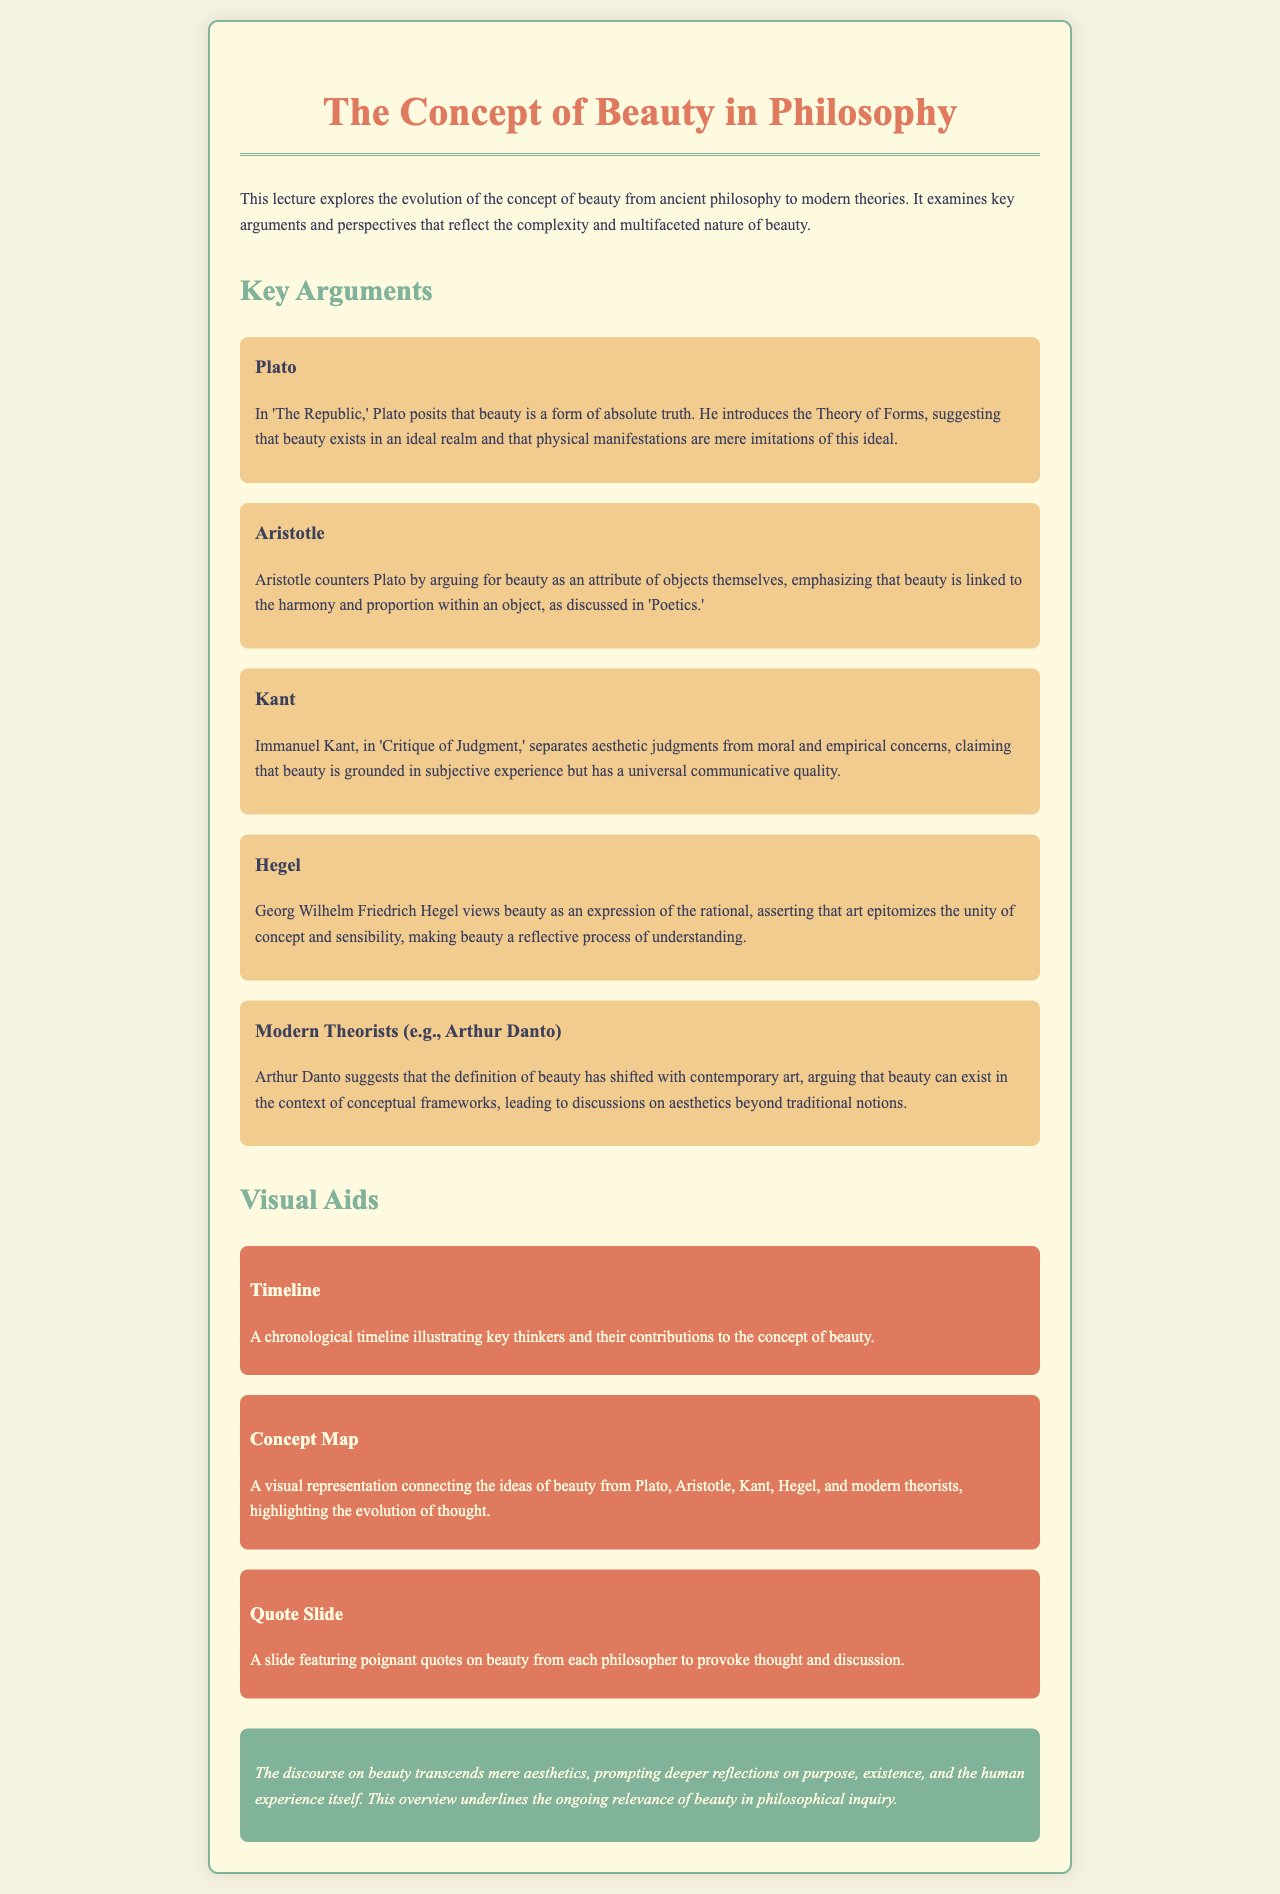What is the title of the lecture? The title is presented prominently at the beginning of the document, summarizing the main subject of discussion.
Answer: The Concept of Beauty in Philosophy Who introduces the Theory of Forms? This information is given in the section about Plato, describing his philosophical contributions.
Answer: Plato What does Aristotle emphasize about beauty? The content about Aristotle discusses his perspective on beauty being linked to harmony and proportion within an object.
Answer: Harmony and proportion In which work does Kant discuss beauty? Kant's discussion on beauty is mentioned along with the title of his influential work.
Answer: Critique of Judgment What visual aid illustrates key thinkers? The document mentions various visual aids that complement the lecture material.
Answer: Timeline Which philosopher suggests that beauty exists within conceptual frameworks? This detail is found in the section regarding modern theorists, highlighting contemporary views.
Answer: Arthur Danto What color represents the conclusion section? The conclusion is designed with a specific color as part of the aesthetic structure of the document.
Answer: #81b29a How many philosophers are discussed in the lecture? The document lists several key thinkers, indicating the number of philosophers whose ideas are covered.
Answer: Five What is the focus of the lecture's conclusion? The conclusion provides insights into the broader implications of beauty in philosophy, signaling its continued relevance.
Answer: Human experience 